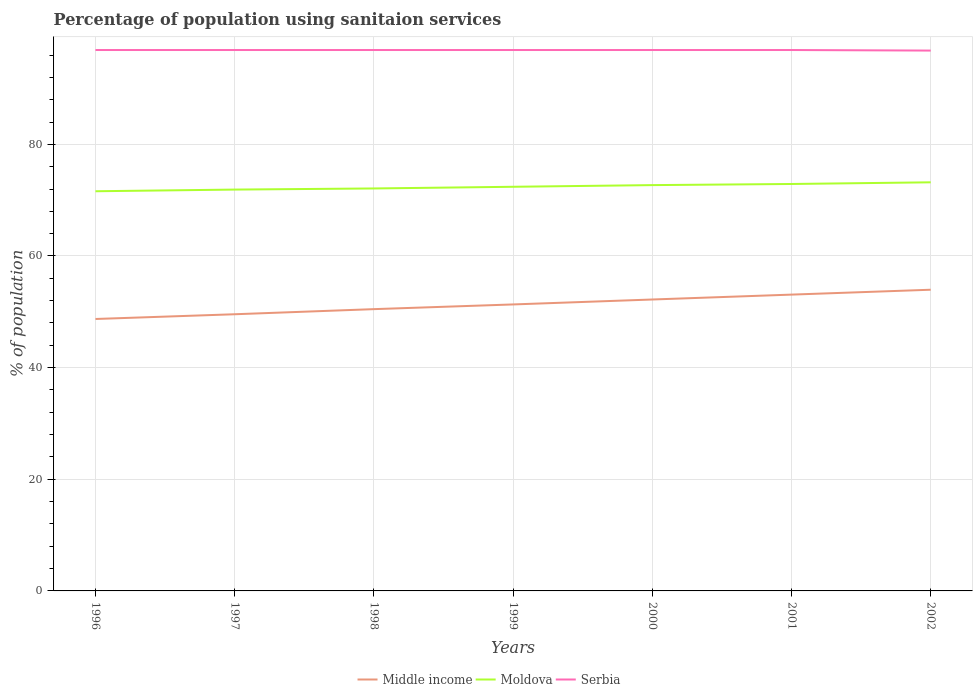Is the number of lines equal to the number of legend labels?
Your answer should be compact. Yes. Across all years, what is the maximum percentage of population using sanitaion services in Serbia?
Offer a terse response. 96.8. In which year was the percentage of population using sanitaion services in Middle income maximum?
Offer a very short reply. 1996. What is the total percentage of population using sanitaion services in Serbia in the graph?
Give a very brief answer. 0. What is the difference between the highest and the second highest percentage of population using sanitaion services in Moldova?
Provide a succinct answer. 1.6. What is the difference between the highest and the lowest percentage of population using sanitaion services in Serbia?
Offer a very short reply. 6. How many years are there in the graph?
Provide a short and direct response. 7. What is the difference between two consecutive major ticks on the Y-axis?
Provide a succinct answer. 20. How are the legend labels stacked?
Provide a succinct answer. Horizontal. What is the title of the graph?
Your answer should be very brief. Percentage of population using sanitaion services. What is the label or title of the Y-axis?
Offer a very short reply. % of population. What is the % of population in Middle income in 1996?
Give a very brief answer. 48.72. What is the % of population of Moldova in 1996?
Your answer should be very brief. 71.6. What is the % of population in Serbia in 1996?
Offer a very short reply. 96.9. What is the % of population in Middle income in 1997?
Ensure brevity in your answer.  49.56. What is the % of population of Moldova in 1997?
Make the answer very short. 71.9. What is the % of population in Serbia in 1997?
Make the answer very short. 96.9. What is the % of population in Middle income in 1998?
Provide a short and direct response. 50.48. What is the % of population in Moldova in 1998?
Make the answer very short. 72.1. What is the % of population of Serbia in 1998?
Your response must be concise. 96.9. What is the % of population in Middle income in 1999?
Keep it short and to the point. 51.32. What is the % of population of Moldova in 1999?
Your response must be concise. 72.4. What is the % of population of Serbia in 1999?
Offer a terse response. 96.9. What is the % of population in Middle income in 2000?
Your answer should be very brief. 52.21. What is the % of population of Moldova in 2000?
Your response must be concise. 72.7. What is the % of population of Serbia in 2000?
Your answer should be very brief. 96.9. What is the % of population in Middle income in 2001?
Provide a succinct answer. 53.08. What is the % of population of Moldova in 2001?
Offer a very short reply. 72.9. What is the % of population of Serbia in 2001?
Your answer should be very brief. 96.9. What is the % of population in Middle income in 2002?
Your response must be concise. 53.96. What is the % of population of Moldova in 2002?
Give a very brief answer. 73.2. What is the % of population of Serbia in 2002?
Offer a terse response. 96.8. Across all years, what is the maximum % of population in Middle income?
Give a very brief answer. 53.96. Across all years, what is the maximum % of population in Moldova?
Your answer should be compact. 73.2. Across all years, what is the maximum % of population of Serbia?
Give a very brief answer. 96.9. Across all years, what is the minimum % of population in Middle income?
Your answer should be compact. 48.72. Across all years, what is the minimum % of population of Moldova?
Ensure brevity in your answer.  71.6. Across all years, what is the minimum % of population of Serbia?
Make the answer very short. 96.8. What is the total % of population in Middle income in the graph?
Your answer should be very brief. 359.33. What is the total % of population in Moldova in the graph?
Offer a very short reply. 506.8. What is the total % of population of Serbia in the graph?
Provide a short and direct response. 678.2. What is the difference between the % of population in Middle income in 1996 and that in 1997?
Offer a very short reply. -0.85. What is the difference between the % of population in Middle income in 1996 and that in 1998?
Provide a succinct answer. -1.76. What is the difference between the % of population of Moldova in 1996 and that in 1998?
Give a very brief answer. -0.5. What is the difference between the % of population in Serbia in 1996 and that in 1998?
Provide a short and direct response. 0. What is the difference between the % of population of Middle income in 1996 and that in 1999?
Provide a succinct answer. -2.61. What is the difference between the % of population in Serbia in 1996 and that in 1999?
Ensure brevity in your answer.  0. What is the difference between the % of population in Middle income in 1996 and that in 2000?
Keep it short and to the point. -3.49. What is the difference between the % of population of Moldova in 1996 and that in 2000?
Make the answer very short. -1.1. What is the difference between the % of population of Serbia in 1996 and that in 2000?
Keep it short and to the point. 0. What is the difference between the % of population in Middle income in 1996 and that in 2001?
Provide a short and direct response. -4.36. What is the difference between the % of population in Middle income in 1996 and that in 2002?
Provide a succinct answer. -5.24. What is the difference between the % of population in Moldova in 1996 and that in 2002?
Keep it short and to the point. -1.6. What is the difference between the % of population of Serbia in 1996 and that in 2002?
Offer a very short reply. 0.1. What is the difference between the % of population in Middle income in 1997 and that in 1998?
Provide a succinct answer. -0.92. What is the difference between the % of population in Middle income in 1997 and that in 1999?
Provide a short and direct response. -1.76. What is the difference between the % of population in Moldova in 1997 and that in 1999?
Offer a very short reply. -0.5. What is the difference between the % of population in Serbia in 1997 and that in 1999?
Offer a very short reply. 0. What is the difference between the % of population in Middle income in 1997 and that in 2000?
Provide a succinct answer. -2.64. What is the difference between the % of population of Serbia in 1997 and that in 2000?
Your answer should be compact. 0. What is the difference between the % of population in Middle income in 1997 and that in 2001?
Ensure brevity in your answer.  -3.52. What is the difference between the % of population in Middle income in 1997 and that in 2002?
Your answer should be compact. -4.39. What is the difference between the % of population in Middle income in 1998 and that in 1999?
Provide a succinct answer. -0.84. What is the difference between the % of population of Moldova in 1998 and that in 1999?
Your response must be concise. -0.3. What is the difference between the % of population in Serbia in 1998 and that in 1999?
Your answer should be very brief. 0. What is the difference between the % of population of Middle income in 1998 and that in 2000?
Make the answer very short. -1.73. What is the difference between the % of population in Moldova in 1998 and that in 2000?
Provide a short and direct response. -0.6. What is the difference between the % of population of Serbia in 1998 and that in 2000?
Make the answer very short. 0. What is the difference between the % of population in Middle income in 1998 and that in 2001?
Provide a succinct answer. -2.6. What is the difference between the % of population in Serbia in 1998 and that in 2001?
Make the answer very short. 0. What is the difference between the % of population in Middle income in 1998 and that in 2002?
Keep it short and to the point. -3.48. What is the difference between the % of population of Middle income in 1999 and that in 2000?
Provide a succinct answer. -0.88. What is the difference between the % of population of Middle income in 1999 and that in 2001?
Give a very brief answer. -1.76. What is the difference between the % of population in Moldova in 1999 and that in 2001?
Your answer should be compact. -0.5. What is the difference between the % of population in Serbia in 1999 and that in 2001?
Your answer should be compact. 0. What is the difference between the % of population in Middle income in 1999 and that in 2002?
Keep it short and to the point. -2.63. What is the difference between the % of population of Moldova in 1999 and that in 2002?
Make the answer very short. -0.8. What is the difference between the % of population in Serbia in 1999 and that in 2002?
Your answer should be compact. 0.1. What is the difference between the % of population in Middle income in 2000 and that in 2001?
Offer a very short reply. -0.88. What is the difference between the % of population of Middle income in 2000 and that in 2002?
Give a very brief answer. -1.75. What is the difference between the % of population of Moldova in 2000 and that in 2002?
Your answer should be compact. -0.5. What is the difference between the % of population of Middle income in 2001 and that in 2002?
Offer a terse response. -0.88. What is the difference between the % of population in Serbia in 2001 and that in 2002?
Keep it short and to the point. 0.1. What is the difference between the % of population in Middle income in 1996 and the % of population in Moldova in 1997?
Ensure brevity in your answer.  -23.18. What is the difference between the % of population in Middle income in 1996 and the % of population in Serbia in 1997?
Give a very brief answer. -48.18. What is the difference between the % of population of Moldova in 1996 and the % of population of Serbia in 1997?
Make the answer very short. -25.3. What is the difference between the % of population in Middle income in 1996 and the % of population in Moldova in 1998?
Keep it short and to the point. -23.38. What is the difference between the % of population of Middle income in 1996 and the % of population of Serbia in 1998?
Ensure brevity in your answer.  -48.18. What is the difference between the % of population in Moldova in 1996 and the % of population in Serbia in 1998?
Keep it short and to the point. -25.3. What is the difference between the % of population in Middle income in 1996 and the % of population in Moldova in 1999?
Give a very brief answer. -23.68. What is the difference between the % of population in Middle income in 1996 and the % of population in Serbia in 1999?
Make the answer very short. -48.18. What is the difference between the % of population in Moldova in 1996 and the % of population in Serbia in 1999?
Make the answer very short. -25.3. What is the difference between the % of population of Middle income in 1996 and the % of population of Moldova in 2000?
Your answer should be very brief. -23.98. What is the difference between the % of population of Middle income in 1996 and the % of population of Serbia in 2000?
Provide a short and direct response. -48.18. What is the difference between the % of population in Moldova in 1996 and the % of population in Serbia in 2000?
Your answer should be very brief. -25.3. What is the difference between the % of population in Middle income in 1996 and the % of population in Moldova in 2001?
Provide a succinct answer. -24.18. What is the difference between the % of population of Middle income in 1996 and the % of population of Serbia in 2001?
Make the answer very short. -48.18. What is the difference between the % of population in Moldova in 1996 and the % of population in Serbia in 2001?
Make the answer very short. -25.3. What is the difference between the % of population in Middle income in 1996 and the % of population in Moldova in 2002?
Ensure brevity in your answer.  -24.48. What is the difference between the % of population in Middle income in 1996 and the % of population in Serbia in 2002?
Provide a succinct answer. -48.08. What is the difference between the % of population of Moldova in 1996 and the % of population of Serbia in 2002?
Ensure brevity in your answer.  -25.2. What is the difference between the % of population of Middle income in 1997 and the % of population of Moldova in 1998?
Make the answer very short. -22.54. What is the difference between the % of population of Middle income in 1997 and the % of population of Serbia in 1998?
Make the answer very short. -47.34. What is the difference between the % of population in Moldova in 1997 and the % of population in Serbia in 1998?
Your response must be concise. -25. What is the difference between the % of population of Middle income in 1997 and the % of population of Moldova in 1999?
Provide a short and direct response. -22.84. What is the difference between the % of population in Middle income in 1997 and the % of population in Serbia in 1999?
Offer a terse response. -47.34. What is the difference between the % of population in Moldova in 1997 and the % of population in Serbia in 1999?
Ensure brevity in your answer.  -25. What is the difference between the % of population of Middle income in 1997 and the % of population of Moldova in 2000?
Offer a very short reply. -23.14. What is the difference between the % of population of Middle income in 1997 and the % of population of Serbia in 2000?
Give a very brief answer. -47.34. What is the difference between the % of population in Moldova in 1997 and the % of population in Serbia in 2000?
Ensure brevity in your answer.  -25. What is the difference between the % of population of Middle income in 1997 and the % of population of Moldova in 2001?
Offer a terse response. -23.34. What is the difference between the % of population of Middle income in 1997 and the % of population of Serbia in 2001?
Give a very brief answer. -47.34. What is the difference between the % of population of Middle income in 1997 and the % of population of Moldova in 2002?
Keep it short and to the point. -23.64. What is the difference between the % of population of Middle income in 1997 and the % of population of Serbia in 2002?
Give a very brief answer. -47.24. What is the difference between the % of population of Moldova in 1997 and the % of population of Serbia in 2002?
Keep it short and to the point. -24.9. What is the difference between the % of population in Middle income in 1998 and the % of population in Moldova in 1999?
Keep it short and to the point. -21.92. What is the difference between the % of population of Middle income in 1998 and the % of population of Serbia in 1999?
Offer a terse response. -46.42. What is the difference between the % of population in Moldova in 1998 and the % of population in Serbia in 1999?
Offer a terse response. -24.8. What is the difference between the % of population in Middle income in 1998 and the % of population in Moldova in 2000?
Provide a short and direct response. -22.22. What is the difference between the % of population of Middle income in 1998 and the % of population of Serbia in 2000?
Give a very brief answer. -46.42. What is the difference between the % of population of Moldova in 1998 and the % of population of Serbia in 2000?
Offer a very short reply. -24.8. What is the difference between the % of population in Middle income in 1998 and the % of population in Moldova in 2001?
Ensure brevity in your answer.  -22.42. What is the difference between the % of population in Middle income in 1998 and the % of population in Serbia in 2001?
Keep it short and to the point. -46.42. What is the difference between the % of population of Moldova in 1998 and the % of population of Serbia in 2001?
Make the answer very short. -24.8. What is the difference between the % of population in Middle income in 1998 and the % of population in Moldova in 2002?
Ensure brevity in your answer.  -22.72. What is the difference between the % of population of Middle income in 1998 and the % of population of Serbia in 2002?
Give a very brief answer. -46.32. What is the difference between the % of population of Moldova in 1998 and the % of population of Serbia in 2002?
Ensure brevity in your answer.  -24.7. What is the difference between the % of population in Middle income in 1999 and the % of population in Moldova in 2000?
Provide a succinct answer. -21.38. What is the difference between the % of population in Middle income in 1999 and the % of population in Serbia in 2000?
Offer a very short reply. -45.58. What is the difference between the % of population of Moldova in 1999 and the % of population of Serbia in 2000?
Provide a short and direct response. -24.5. What is the difference between the % of population of Middle income in 1999 and the % of population of Moldova in 2001?
Ensure brevity in your answer.  -21.58. What is the difference between the % of population in Middle income in 1999 and the % of population in Serbia in 2001?
Your response must be concise. -45.58. What is the difference between the % of population in Moldova in 1999 and the % of population in Serbia in 2001?
Your answer should be very brief. -24.5. What is the difference between the % of population of Middle income in 1999 and the % of population of Moldova in 2002?
Provide a short and direct response. -21.88. What is the difference between the % of population of Middle income in 1999 and the % of population of Serbia in 2002?
Make the answer very short. -45.48. What is the difference between the % of population of Moldova in 1999 and the % of population of Serbia in 2002?
Your answer should be very brief. -24.4. What is the difference between the % of population in Middle income in 2000 and the % of population in Moldova in 2001?
Ensure brevity in your answer.  -20.69. What is the difference between the % of population of Middle income in 2000 and the % of population of Serbia in 2001?
Offer a terse response. -44.69. What is the difference between the % of population in Moldova in 2000 and the % of population in Serbia in 2001?
Provide a succinct answer. -24.2. What is the difference between the % of population of Middle income in 2000 and the % of population of Moldova in 2002?
Your answer should be very brief. -20.99. What is the difference between the % of population in Middle income in 2000 and the % of population in Serbia in 2002?
Provide a succinct answer. -44.59. What is the difference between the % of population in Moldova in 2000 and the % of population in Serbia in 2002?
Your answer should be very brief. -24.1. What is the difference between the % of population in Middle income in 2001 and the % of population in Moldova in 2002?
Provide a succinct answer. -20.12. What is the difference between the % of population in Middle income in 2001 and the % of population in Serbia in 2002?
Offer a very short reply. -43.72. What is the difference between the % of population of Moldova in 2001 and the % of population of Serbia in 2002?
Ensure brevity in your answer.  -23.9. What is the average % of population of Middle income per year?
Offer a terse response. 51.33. What is the average % of population of Moldova per year?
Offer a very short reply. 72.4. What is the average % of population of Serbia per year?
Keep it short and to the point. 96.89. In the year 1996, what is the difference between the % of population in Middle income and % of population in Moldova?
Make the answer very short. -22.88. In the year 1996, what is the difference between the % of population in Middle income and % of population in Serbia?
Provide a short and direct response. -48.18. In the year 1996, what is the difference between the % of population of Moldova and % of population of Serbia?
Keep it short and to the point. -25.3. In the year 1997, what is the difference between the % of population of Middle income and % of population of Moldova?
Your answer should be very brief. -22.34. In the year 1997, what is the difference between the % of population of Middle income and % of population of Serbia?
Your response must be concise. -47.34. In the year 1997, what is the difference between the % of population in Moldova and % of population in Serbia?
Give a very brief answer. -25. In the year 1998, what is the difference between the % of population in Middle income and % of population in Moldova?
Ensure brevity in your answer.  -21.62. In the year 1998, what is the difference between the % of population of Middle income and % of population of Serbia?
Your response must be concise. -46.42. In the year 1998, what is the difference between the % of population in Moldova and % of population in Serbia?
Provide a short and direct response. -24.8. In the year 1999, what is the difference between the % of population of Middle income and % of population of Moldova?
Make the answer very short. -21.08. In the year 1999, what is the difference between the % of population of Middle income and % of population of Serbia?
Provide a short and direct response. -45.58. In the year 1999, what is the difference between the % of population of Moldova and % of population of Serbia?
Provide a succinct answer. -24.5. In the year 2000, what is the difference between the % of population of Middle income and % of population of Moldova?
Your answer should be very brief. -20.49. In the year 2000, what is the difference between the % of population of Middle income and % of population of Serbia?
Your answer should be very brief. -44.69. In the year 2000, what is the difference between the % of population in Moldova and % of population in Serbia?
Your answer should be compact. -24.2. In the year 2001, what is the difference between the % of population of Middle income and % of population of Moldova?
Offer a very short reply. -19.82. In the year 2001, what is the difference between the % of population of Middle income and % of population of Serbia?
Provide a short and direct response. -43.82. In the year 2002, what is the difference between the % of population in Middle income and % of population in Moldova?
Offer a very short reply. -19.24. In the year 2002, what is the difference between the % of population in Middle income and % of population in Serbia?
Offer a very short reply. -42.84. In the year 2002, what is the difference between the % of population of Moldova and % of population of Serbia?
Your response must be concise. -23.6. What is the ratio of the % of population in Middle income in 1996 to that in 1997?
Keep it short and to the point. 0.98. What is the ratio of the % of population in Serbia in 1996 to that in 1997?
Give a very brief answer. 1. What is the ratio of the % of population in Middle income in 1996 to that in 1998?
Your response must be concise. 0.97. What is the ratio of the % of population of Moldova in 1996 to that in 1998?
Your answer should be very brief. 0.99. What is the ratio of the % of population in Middle income in 1996 to that in 1999?
Provide a short and direct response. 0.95. What is the ratio of the % of population of Moldova in 1996 to that in 1999?
Provide a succinct answer. 0.99. What is the ratio of the % of population of Serbia in 1996 to that in 1999?
Give a very brief answer. 1. What is the ratio of the % of population of Middle income in 1996 to that in 2000?
Give a very brief answer. 0.93. What is the ratio of the % of population in Moldova in 1996 to that in 2000?
Your answer should be compact. 0.98. What is the ratio of the % of population of Middle income in 1996 to that in 2001?
Offer a very short reply. 0.92. What is the ratio of the % of population of Moldova in 1996 to that in 2001?
Provide a short and direct response. 0.98. What is the ratio of the % of population of Serbia in 1996 to that in 2001?
Keep it short and to the point. 1. What is the ratio of the % of population of Middle income in 1996 to that in 2002?
Provide a succinct answer. 0.9. What is the ratio of the % of population in Moldova in 1996 to that in 2002?
Your answer should be compact. 0.98. What is the ratio of the % of population in Serbia in 1996 to that in 2002?
Provide a succinct answer. 1. What is the ratio of the % of population of Middle income in 1997 to that in 1998?
Ensure brevity in your answer.  0.98. What is the ratio of the % of population of Serbia in 1997 to that in 1998?
Ensure brevity in your answer.  1. What is the ratio of the % of population in Middle income in 1997 to that in 1999?
Make the answer very short. 0.97. What is the ratio of the % of population of Moldova in 1997 to that in 1999?
Offer a terse response. 0.99. What is the ratio of the % of population of Middle income in 1997 to that in 2000?
Your response must be concise. 0.95. What is the ratio of the % of population of Serbia in 1997 to that in 2000?
Your answer should be compact. 1. What is the ratio of the % of population in Middle income in 1997 to that in 2001?
Your response must be concise. 0.93. What is the ratio of the % of population in Moldova in 1997 to that in 2001?
Offer a very short reply. 0.99. What is the ratio of the % of population of Middle income in 1997 to that in 2002?
Keep it short and to the point. 0.92. What is the ratio of the % of population in Moldova in 1997 to that in 2002?
Offer a terse response. 0.98. What is the ratio of the % of population in Middle income in 1998 to that in 1999?
Offer a very short reply. 0.98. What is the ratio of the % of population in Moldova in 1998 to that in 1999?
Keep it short and to the point. 1. What is the ratio of the % of population in Serbia in 1998 to that in 1999?
Keep it short and to the point. 1. What is the ratio of the % of population in Middle income in 1998 to that in 2000?
Offer a terse response. 0.97. What is the ratio of the % of population of Middle income in 1998 to that in 2001?
Offer a terse response. 0.95. What is the ratio of the % of population of Serbia in 1998 to that in 2001?
Offer a very short reply. 1. What is the ratio of the % of population in Middle income in 1998 to that in 2002?
Offer a very short reply. 0.94. What is the ratio of the % of population of Middle income in 1999 to that in 2000?
Ensure brevity in your answer.  0.98. What is the ratio of the % of population of Middle income in 1999 to that in 2001?
Your answer should be compact. 0.97. What is the ratio of the % of population in Moldova in 1999 to that in 2001?
Your answer should be very brief. 0.99. What is the ratio of the % of population in Middle income in 1999 to that in 2002?
Your answer should be compact. 0.95. What is the ratio of the % of population in Moldova in 1999 to that in 2002?
Provide a short and direct response. 0.99. What is the ratio of the % of population of Middle income in 2000 to that in 2001?
Provide a short and direct response. 0.98. What is the ratio of the % of population in Moldova in 2000 to that in 2001?
Your answer should be very brief. 1. What is the ratio of the % of population in Serbia in 2000 to that in 2001?
Ensure brevity in your answer.  1. What is the ratio of the % of population in Middle income in 2000 to that in 2002?
Offer a very short reply. 0.97. What is the ratio of the % of population of Moldova in 2000 to that in 2002?
Your response must be concise. 0.99. What is the ratio of the % of population of Middle income in 2001 to that in 2002?
Make the answer very short. 0.98. What is the ratio of the % of population in Moldova in 2001 to that in 2002?
Ensure brevity in your answer.  1. What is the ratio of the % of population in Serbia in 2001 to that in 2002?
Offer a very short reply. 1. What is the difference between the highest and the second highest % of population of Middle income?
Provide a succinct answer. 0.88. What is the difference between the highest and the second highest % of population of Moldova?
Your answer should be very brief. 0.3. What is the difference between the highest and the lowest % of population of Middle income?
Provide a succinct answer. 5.24. What is the difference between the highest and the lowest % of population of Moldova?
Your answer should be compact. 1.6. 